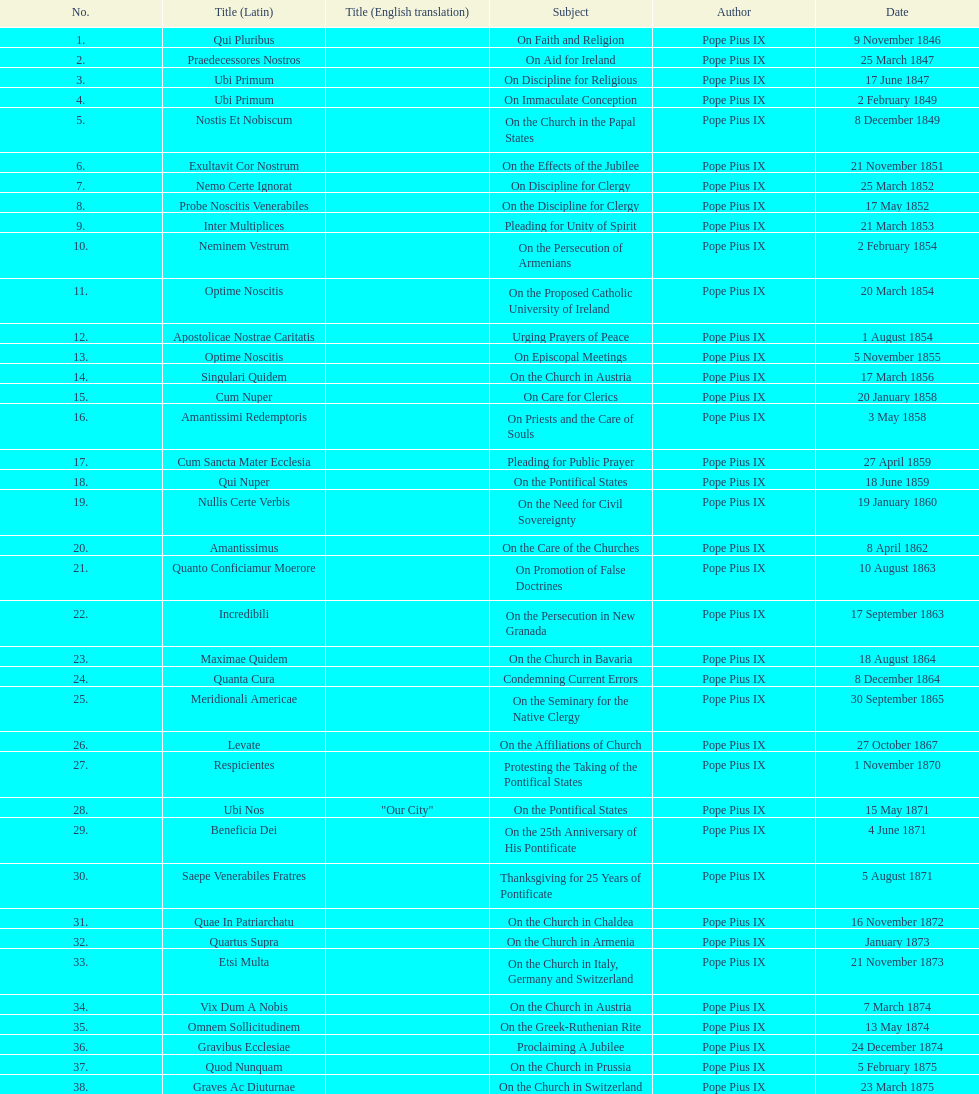What is the total number of title? 38. Could you help me parse every detail presented in this table? {'header': ['No.', 'Title (Latin)', 'Title (English translation)', 'Subject', 'Author', 'Date'], 'rows': [['1.', 'Qui Pluribus', '', 'On Faith and Religion', 'Pope Pius IX', '9 November 1846'], ['2.', 'Praedecessores Nostros', '', 'On Aid for Ireland', 'Pope Pius IX', '25 March 1847'], ['3.', 'Ubi Primum', '', 'On Discipline for Religious', 'Pope Pius IX', '17 June 1847'], ['4.', 'Ubi Primum', '', 'On Immaculate Conception', 'Pope Pius IX', '2 February 1849'], ['5.', 'Nostis Et Nobiscum', '', 'On the Church in the Papal States', 'Pope Pius IX', '8 December 1849'], ['6.', 'Exultavit Cor Nostrum', '', 'On the Effects of the Jubilee', 'Pope Pius IX', '21 November 1851'], ['7.', 'Nemo Certe Ignorat', '', 'On Discipline for Clergy', 'Pope Pius IX', '25 March 1852'], ['8.', 'Probe Noscitis Venerabiles', '', 'On the Discipline for Clergy', 'Pope Pius IX', '17 May 1852'], ['9.', 'Inter Multiplices', '', 'Pleading for Unity of Spirit', 'Pope Pius IX', '21 March 1853'], ['10.', 'Neminem Vestrum', '', 'On the Persecution of Armenians', 'Pope Pius IX', '2 February 1854'], ['11.', 'Optime Noscitis', '', 'On the Proposed Catholic University of Ireland', 'Pope Pius IX', '20 March 1854'], ['12.', 'Apostolicae Nostrae Caritatis', '', 'Urging Prayers of Peace', 'Pope Pius IX', '1 August 1854'], ['13.', 'Optime Noscitis', '', 'On Episcopal Meetings', 'Pope Pius IX', '5 November 1855'], ['14.', 'Singulari Quidem', '', 'On the Church in Austria', 'Pope Pius IX', '17 March 1856'], ['15.', 'Cum Nuper', '', 'On Care for Clerics', 'Pope Pius IX', '20 January 1858'], ['16.', 'Amantissimi Redemptoris', '', 'On Priests and the Care of Souls', 'Pope Pius IX', '3 May 1858'], ['17.', 'Cum Sancta Mater Ecclesia', '', 'Pleading for Public Prayer', 'Pope Pius IX', '27 April 1859'], ['18.', 'Qui Nuper', '', 'On the Pontifical States', 'Pope Pius IX', '18 June 1859'], ['19.', 'Nullis Certe Verbis', '', 'On the Need for Civil Sovereignty', 'Pope Pius IX', '19 January 1860'], ['20.', 'Amantissimus', '', 'On the Care of the Churches', 'Pope Pius IX', '8 April 1862'], ['21.', 'Quanto Conficiamur Moerore', '', 'On Promotion of False Doctrines', 'Pope Pius IX', '10 August 1863'], ['22.', 'Incredibili', '', 'On the Persecution in New Granada', 'Pope Pius IX', '17 September 1863'], ['23.', 'Maximae Quidem', '', 'On the Church in Bavaria', 'Pope Pius IX', '18 August 1864'], ['24.', 'Quanta Cura', '', 'Condemning Current Errors', 'Pope Pius IX', '8 December 1864'], ['25.', 'Meridionali Americae', '', 'On the Seminary for the Native Clergy', 'Pope Pius IX', '30 September 1865'], ['26.', 'Levate', '', 'On the Affiliations of Church', 'Pope Pius IX', '27 October 1867'], ['27.', 'Respicientes', '', 'Protesting the Taking of the Pontifical States', 'Pope Pius IX', '1 November 1870'], ['28.', 'Ubi Nos', '"Our City"', 'On the Pontifical States', 'Pope Pius IX', '15 May 1871'], ['29.', 'Beneficia Dei', '', 'On the 25th Anniversary of His Pontificate', 'Pope Pius IX', '4 June 1871'], ['30.', 'Saepe Venerabiles Fratres', '', 'Thanksgiving for 25 Years of Pontificate', 'Pope Pius IX', '5 August 1871'], ['31.', 'Quae In Patriarchatu', '', 'On the Church in Chaldea', 'Pope Pius IX', '16 November 1872'], ['32.', 'Quartus Supra', '', 'On the Church in Armenia', 'Pope Pius IX', 'January 1873'], ['33.', 'Etsi Multa', '', 'On the Church in Italy, Germany and Switzerland', 'Pope Pius IX', '21 November 1873'], ['34.', 'Vix Dum A Nobis', '', 'On the Church in Austria', 'Pope Pius IX', '7 March 1874'], ['35.', 'Omnem Sollicitudinem', '', 'On the Greek-Ruthenian Rite', 'Pope Pius IX', '13 May 1874'], ['36.', 'Gravibus Ecclesiae', '', 'Proclaiming A Jubilee', 'Pope Pius IX', '24 December 1874'], ['37.', 'Quod Nunquam', '', 'On the Church in Prussia', 'Pope Pius IX', '5 February 1875'], ['38.', 'Graves Ac Diuturnae', '', 'On the Church in Switzerland', 'Pope Pius IX', '23 March 1875']]} 